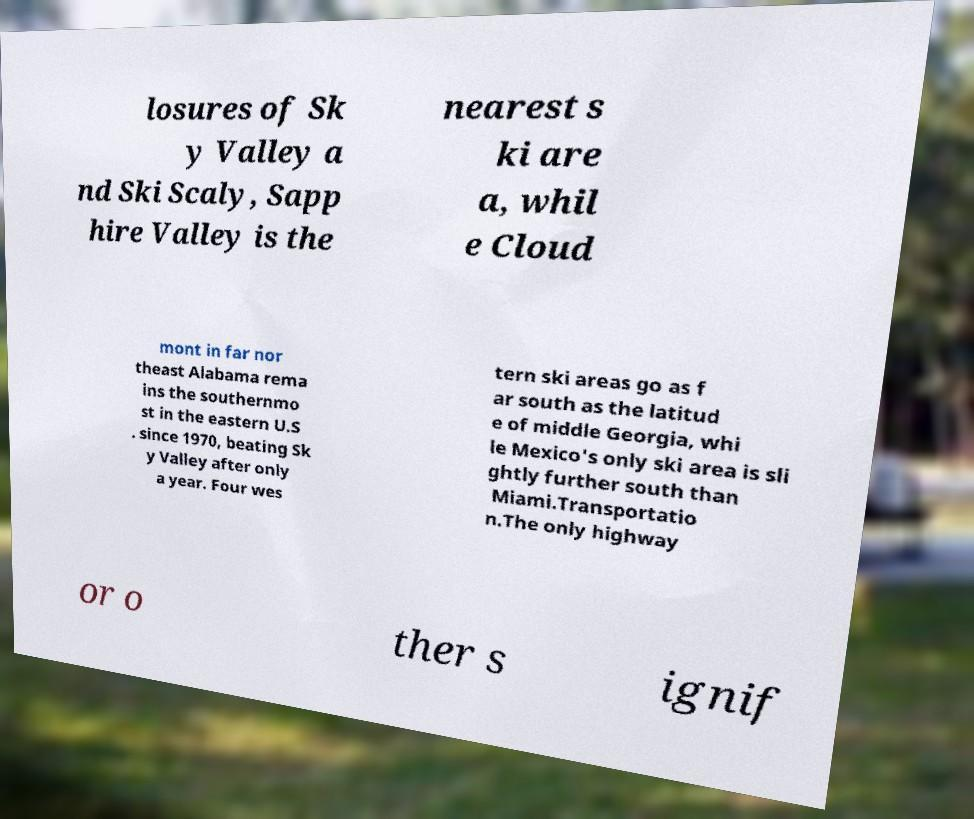Please read and relay the text visible in this image. What does it say? losures of Sk y Valley a nd Ski Scaly, Sapp hire Valley is the nearest s ki are a, whil e Cloud mont in far nor theast Alabama rema ins the southernmo st in the eastern U.S . since 1970, beating Sk y Valley after only a year. Four wes tern ski areas go as f ar south as the latitud e of middle Georgia, whi le Mexico's only ski area is sli ghtly further south than Miami.Transportatio n.The only highway or o ther s ignif 